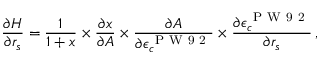<formula> <loc_0><loc_0><loc_500><loc_500>\frac { \partial H } { \partial r _ { s } } = \frac { 1 } { 1 + x } \times \frac { \partial x } { \partial A } \times \frac { \partial A } { \partial \epsilon _ { c } ^ { P W 9 2 } } \times \frac { \partial \epsilon _ { c } ^ { P W 9 2 } } { \partial r _ { s } } \, ,</formula> 